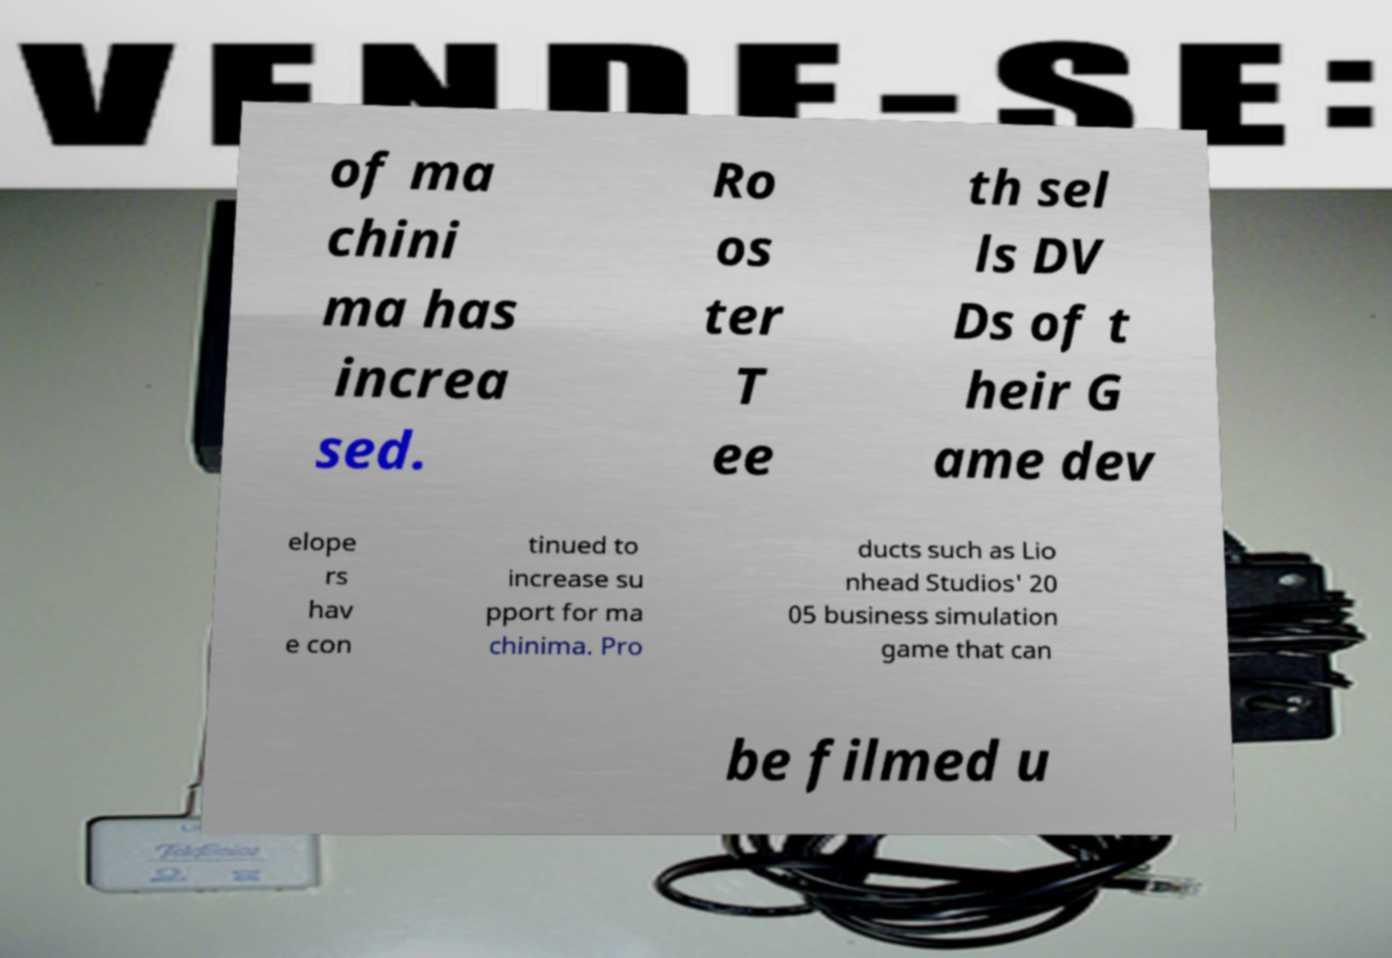Could you extract and type out the text from this image? of ma chini ma has increa sed. Ro os ter T ee th sel ls DV Ds of t heir G ame dev elope rs hav e con tinued to increase su pport for ma chinima. Pro ducts such as Lio nhead Studios' 20 05 business simulation game that can be filmed u 